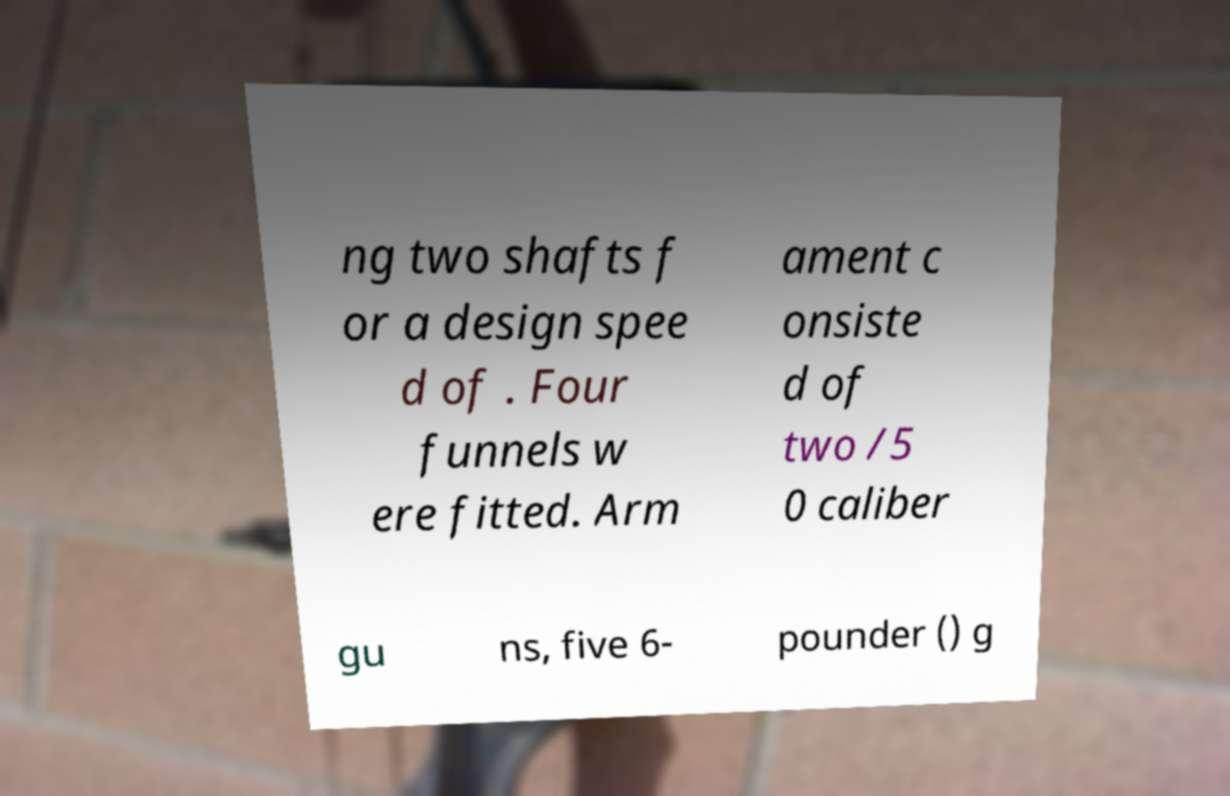Could you assist in decoding the text presented in this image and type it out clearly? ng two shafts f or a design spee d of . Four funnels w ere fitted. Arm ament c onsiste d of two /5 0 caliber gu ns, five 6- pounder () g 